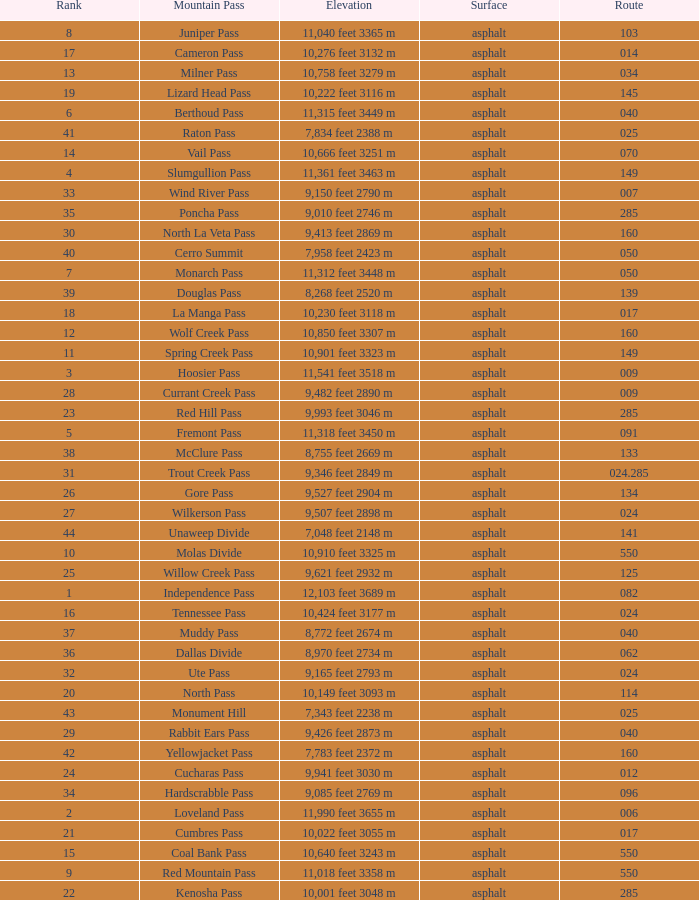What is the Mountain Pass with a 21 Rank? Cumbres Pass. 